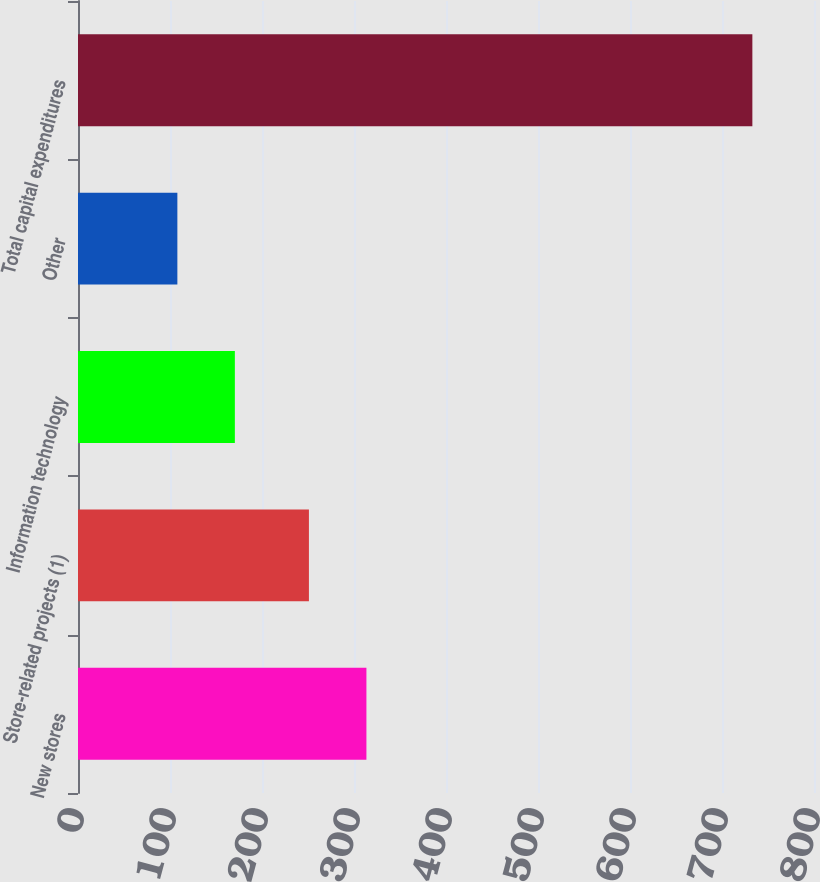Convert chart to OTSL. <chart><loc_0><loc_0><loc_500><loc_500><bar_chart><fcel>New stores<fcel>Store-related projects (1)<fcel>Information technology<fcel>Other<fcel>Total capital expenditures<nl><fcel>313.5<fcel>251<fcel>170.5<fcel>108<fcel>733<nl></chart> 